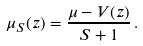<formula> <loc_0><loc_0><loc_500><loc_500>\mu _ { S } ( z ) = { \frac { \mu - V ( z ) } { S + 1 } } \, .</formula> 